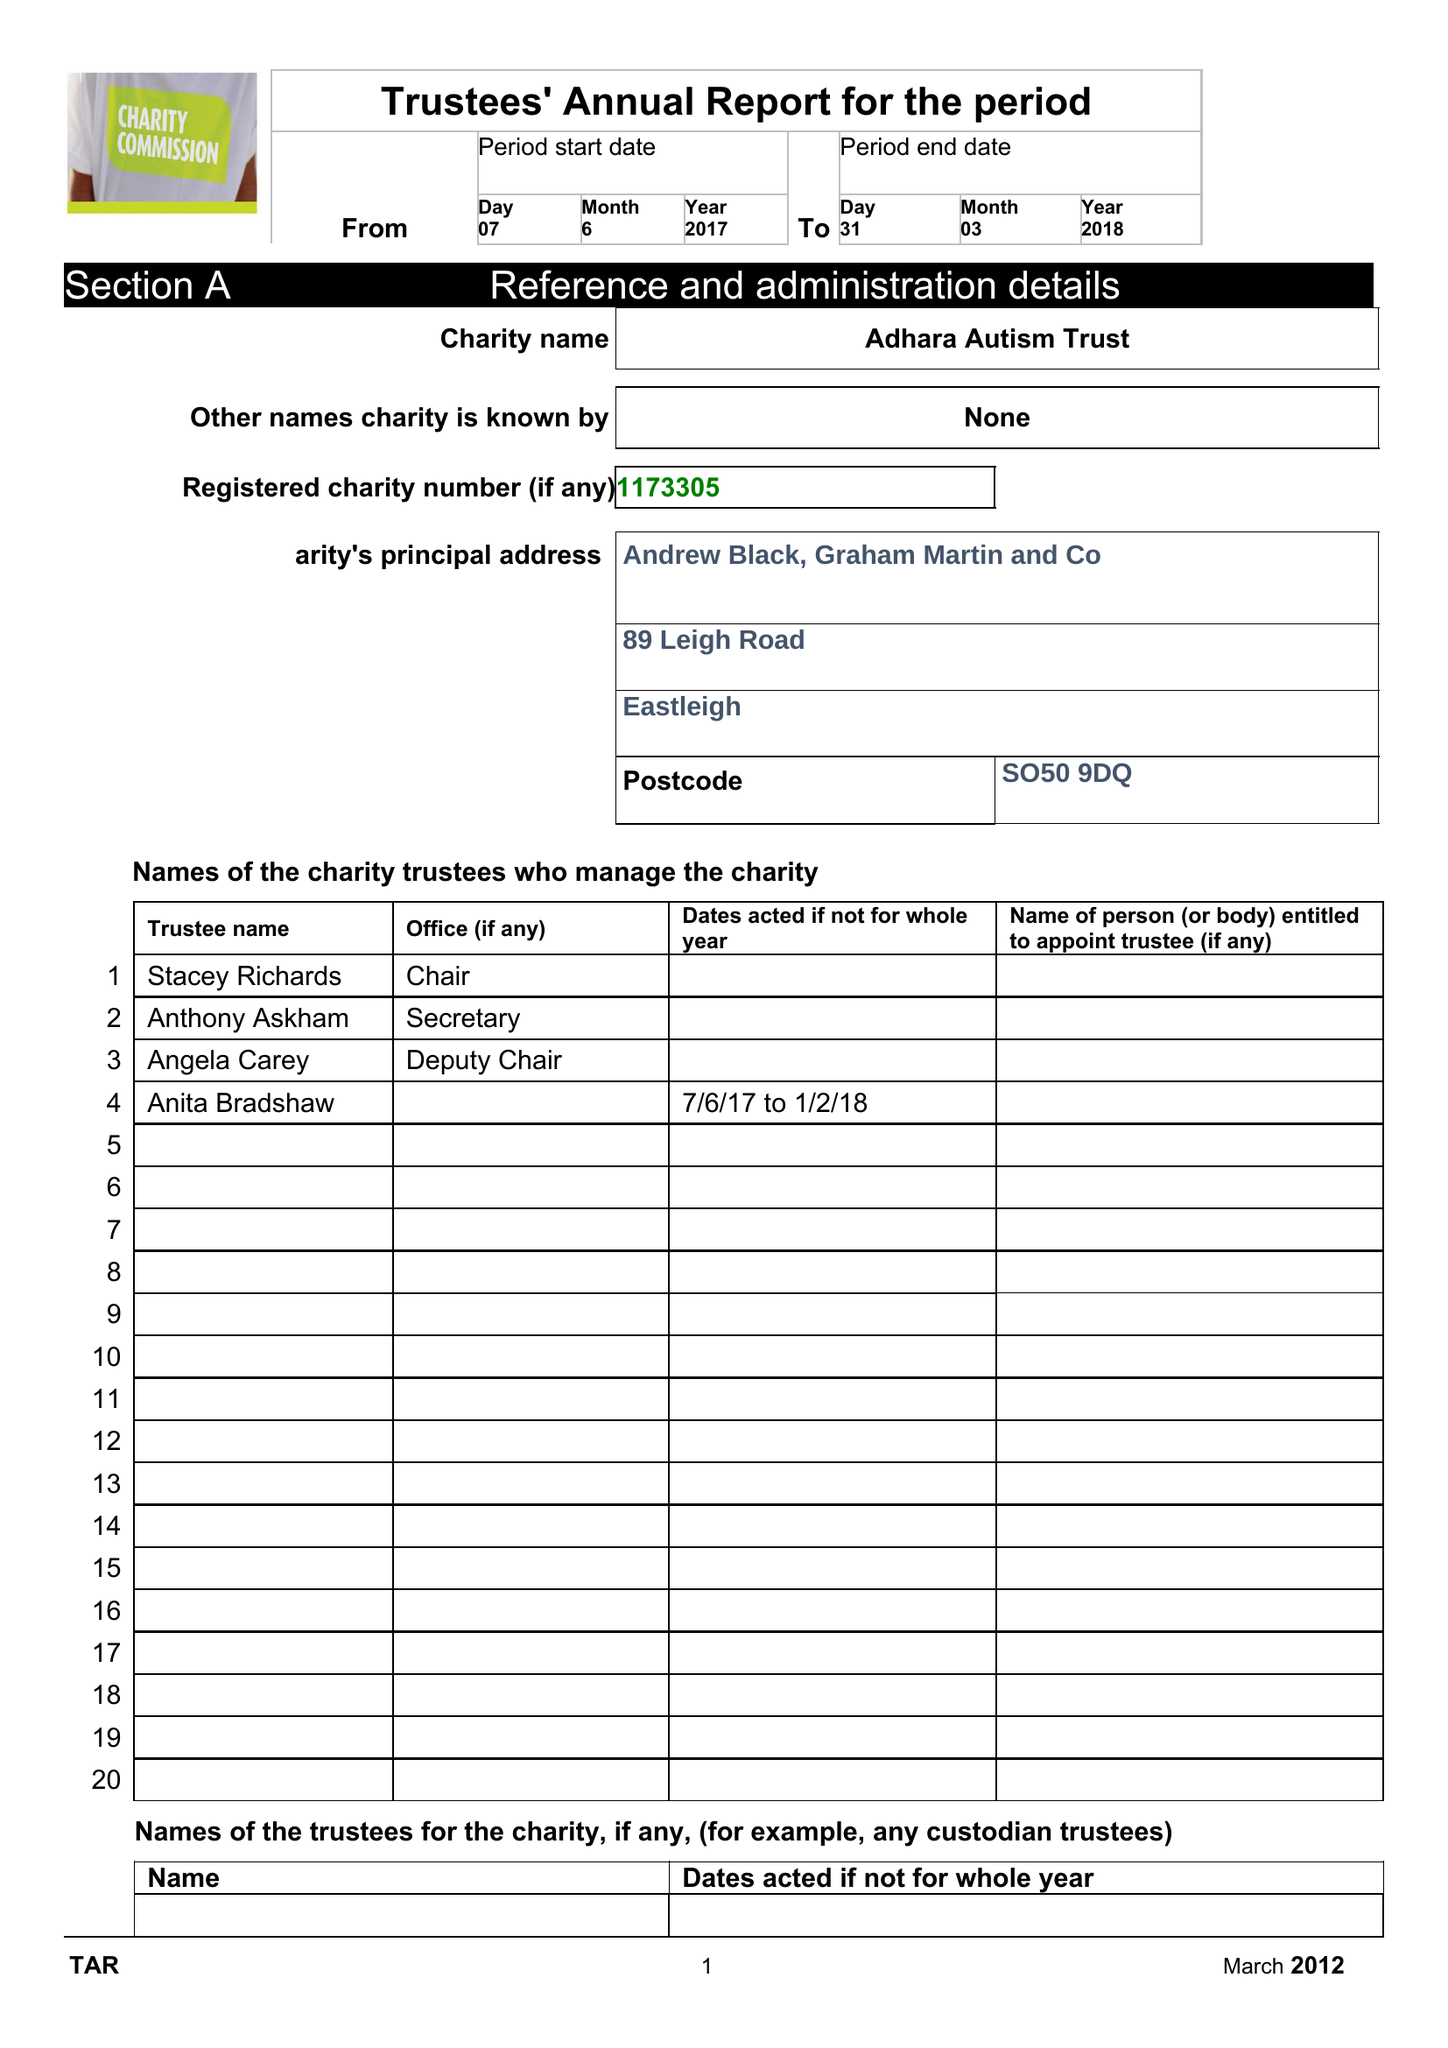What is the value for the income_annually_in_british_pounds?
Answer the question using a single word or phrase. 56.00 